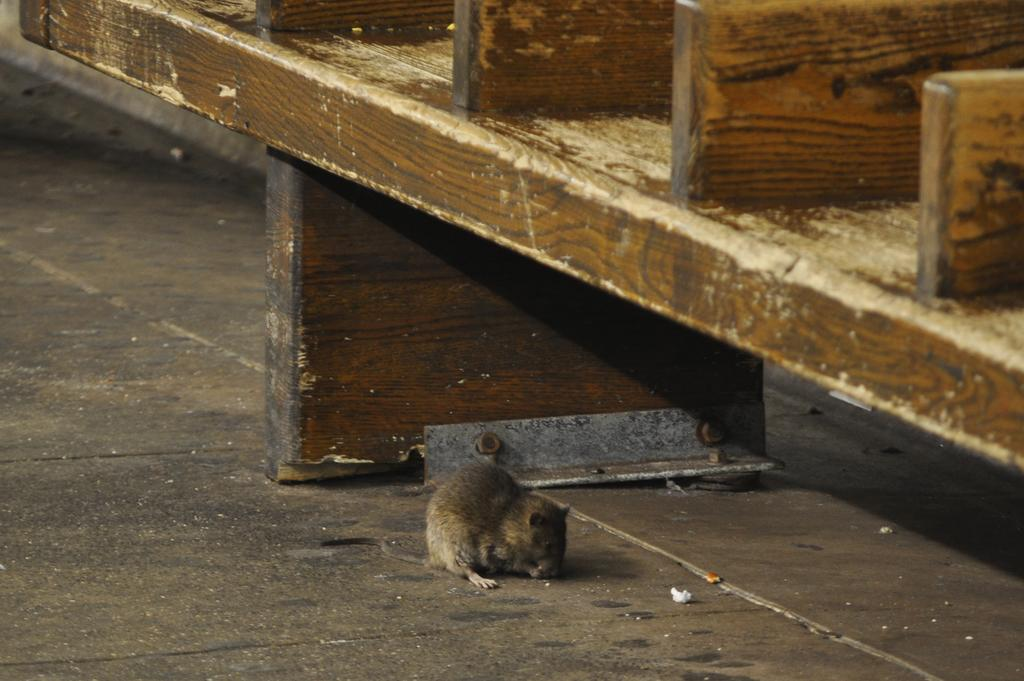What type of animal can be seen on the surface in the image? There is a rat on the surface in the image. What type of structure is present in the image? There is a wooden rack in the image. What type of stem can be seen in the rat's throat in the image? There is no stem or throat visible in the image, as it features a rat on a surface and a wooden rack. 